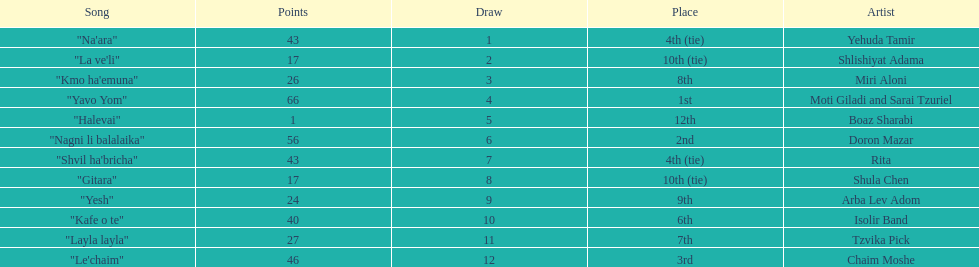Which artist had almost no points? Boaz Sharabi. 